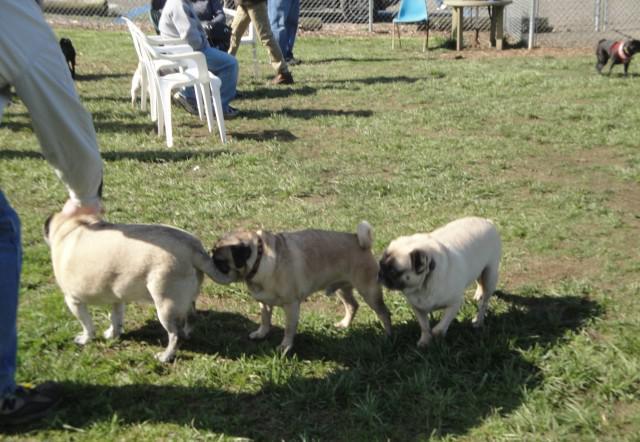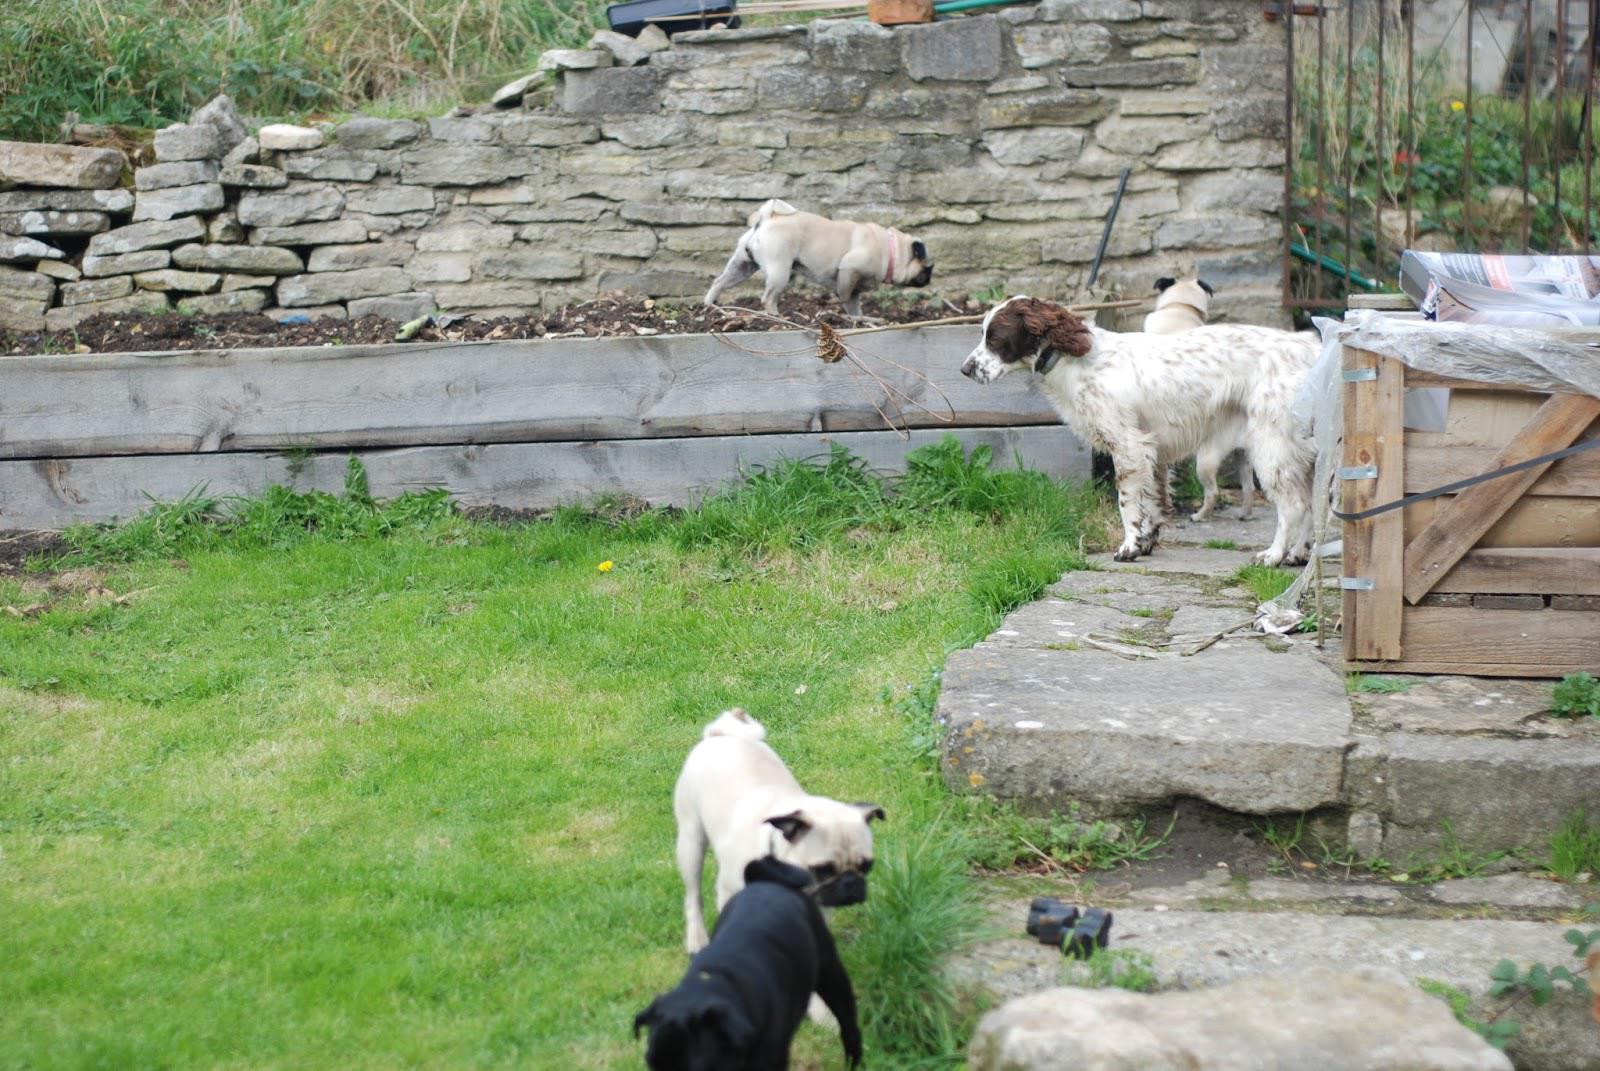The first image is the image on the left, the second image is the image on the right. Given the left and right images, does the statement "At least one person is with the dogs outside in one of the images." hold true? Answer yes or no. Yes. The first image is the image on the left, the second image is the image on the right. For the images shown, is this caption "An image shows exactly one pug dog, which is facing another living creature that is not a pug." true? Answer yes or no. No. 